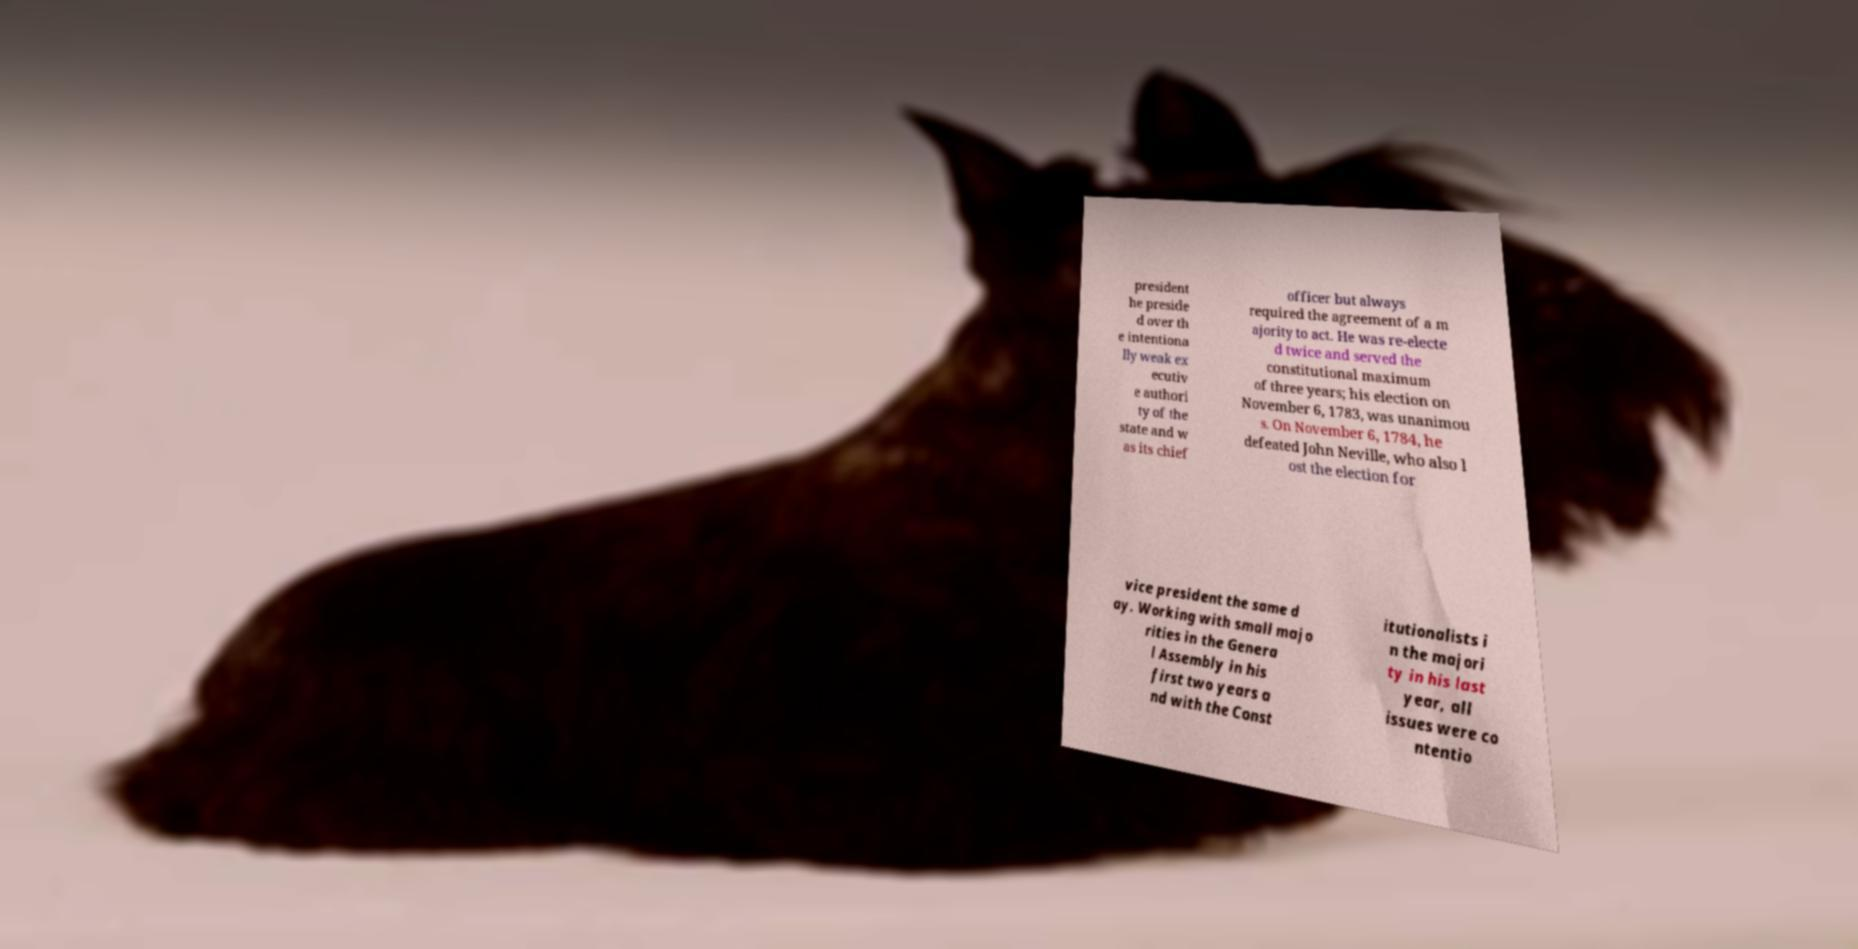Could you assist in decoding the text presented in this image and type it out clearly? president he preside d over th e intentiona lly weak ex ecutiv e authori ty of the state and w as its chief officer but always required the agreement of a m ajority to act. He was re-electe d twice and served the constitutional maximum of three years; his election on November 6, 1783, was unanimou s. On November 6, 1784, he defeated John Neville, who also l ost the election for vice president the same d ay. Working with small majo rities in the Genera l Assembly in his first two years a nd with the Const itutionalists i n the majori ty in his last year, all issues were co ntentio 